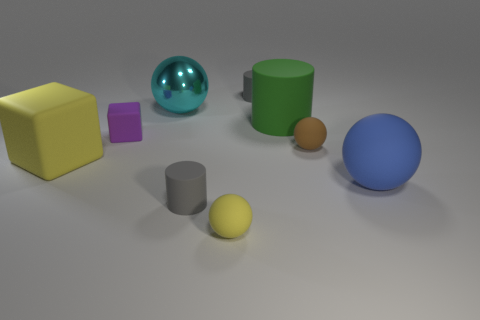How many small yellow matte things are left of the gray thing that is behind the yellow cube?
Your answer should be compact. 1. Are there any small cyan things that have the same shape as the brown rubber object?
Keep it short and to the point. No. There is a big rubber thing behind the small ball that is on the right side of the large green matte cylinder; what color is it?
Offer a terse response. Green. Are there more big rubber spheres than big yellow matte cylinders?
Your answer should be very brief. Yes. How many gray rubber cylinders are the same size as the green matte thing?
Make the answer very short. 0. Does the small yellow object have the same material as the gray thing in front of the big metal sphere?
Provide a succinct answer. Yes. Is the number of tiny yellow balls less than the number of yellow rubber objects?
Your response must be concise. Yes. Is there anything else that is the same color as the large matte block?
Provide a short and direct response. Yes. There is a small purple object that is made of the same material as the blue sphere; what is its shape?
Your answer should be compact. Cube. How many things are on the right side of the large ball that is on the left side of the tiny thing that is behind the big cyan shiny sphere?
Make the answer very short. 6. 